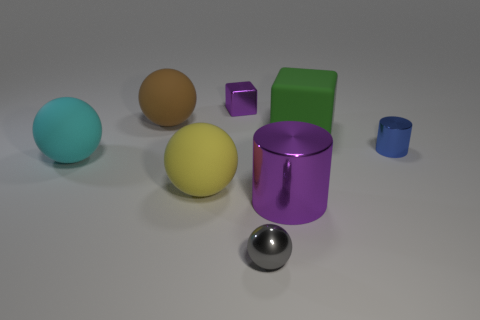What number of big objects are in front of the blue metallic object and on the right side of the tiny cube?
Your answer should be compact. 1. What is the small block made of?
Provide a succinct answer. Metal. There is a green rubber thing that is the same size as the cyan matte sphere; what shape is it?
Make the answer very short. Cube. Are the purple object to the left of the gray sphere and the cylinder on the left side of the blue thing made of the same material?
Make the answer very short. Yes. What number of green cylinders are there?
Your response must be concise. 0. What number of large blue things are the same shape as the gray metal thing?
Your answer should be compact. 0. Do the tiny blue object and the brown matte object have the same shape?
Provide a short and direct response. No. What size is the brown thing?
Offer a terse response. Large. How many blue objects have the same size as the gray ball?
Offer a terse response. 1. There is a purple metallic thing that is right of the gray thing; is its size the same as the cylinder that is behind the yellow object?
Ensure brevity in your answer.  No. 